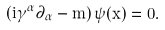Convert formula to latex. <formula><loc_0><loc_0><loc_500><loc_500>( i \gamma ^ { \alpha } \partial _ { \alpha } - m ) \, \psi ( x ) = 0 .</formula> 